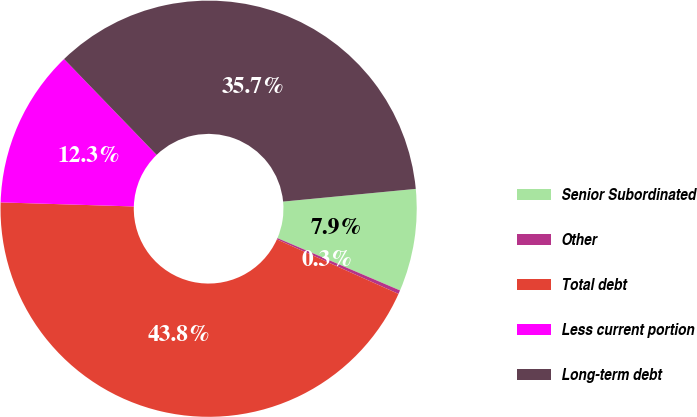Convert chart. <chart><loc_0><loc_0><loc_500><loc_500><pie_chart><fcel>Senior Subordinated<fcel>Other<fcel>Total debt<fcel>Less current portion<fcel>Long-term debt<nl><fcel>7.94%<fcel>0.29%<fcel>43.77%<fcel>12.29%<fcel>35.7%<nl></chart> 